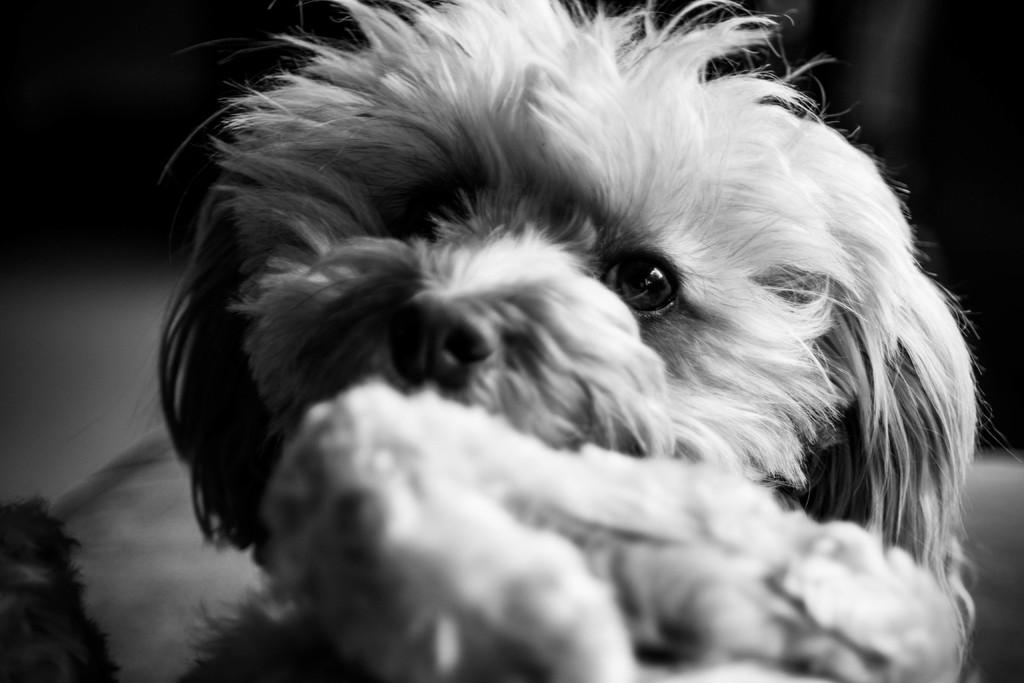What type of animal is in the picture? There is a dog in the picture. Can you describe the dog's appearance? The dog has a full coat of fur. What else can be seen in the picture besides the dog? There is food near the dog. What type of shock can be seen in the image? There is no shock present in the image; it features a dog with a full coat of fur and food nearby. Is there a playground visible in the image? No, there is no playground present in the image. 